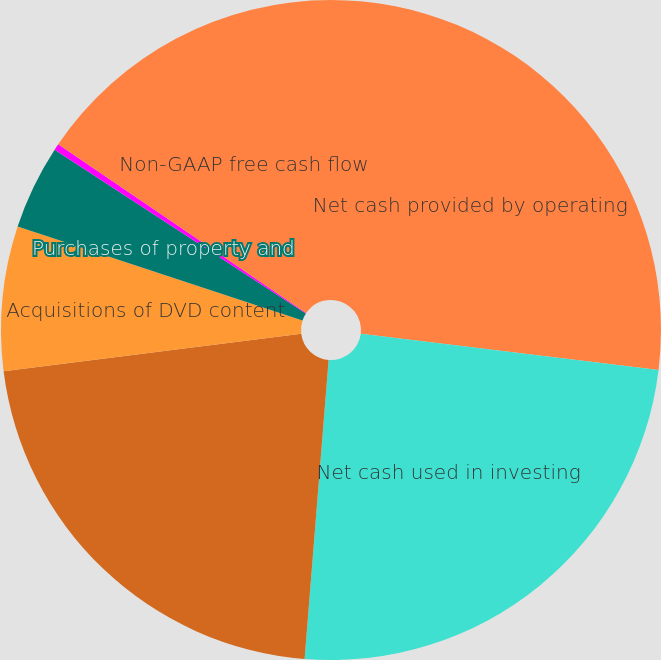Convert chart. <chart><loc_0><loc_0><loc_500><loc_500><pie_chart><fcel>Net cash provided by operating<fcel>Net cash used in investing<fcel>Net cash provided by (used in)<fcel>Acquisitions of DVD content<fcel>Purchases of property and<fcel>Other assets<fcel>Non-GAAP free cash flow<nl><fcel>26.94%<fcel>24.34%<fcel>21.73%<fcel>7.07%<fcel>4.13%<fcel>0.31%<fcel>15.49%<nl></chart> 